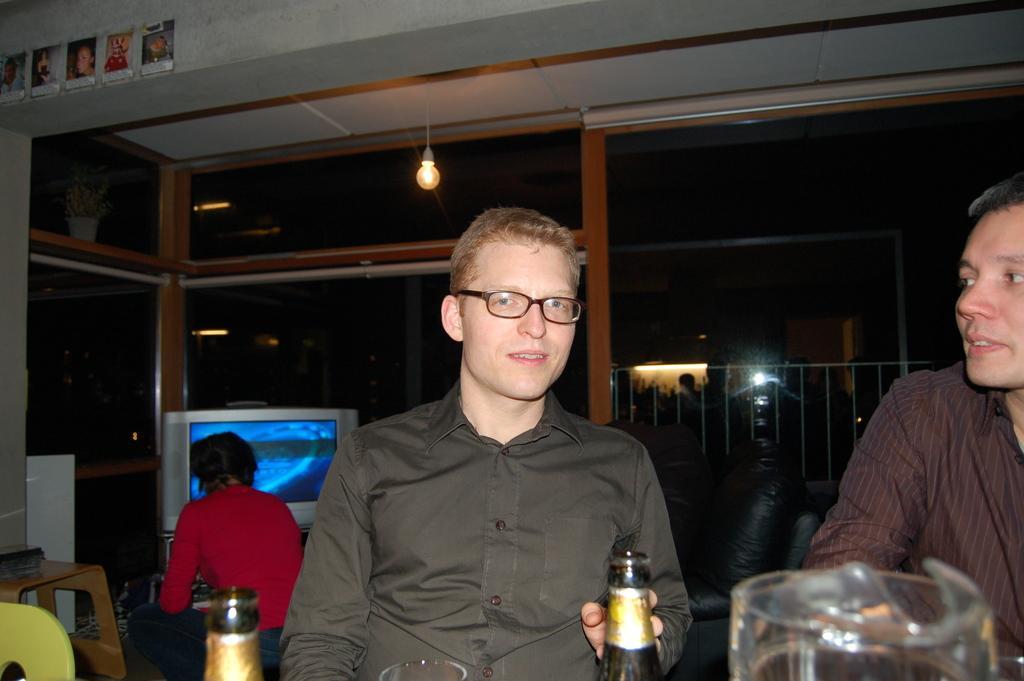Could you give a brief overview of what you see in this image? In this picture we can see two people, in front of them we can see bottles, glass and in the background we can see a person, television, lights and some objects. 